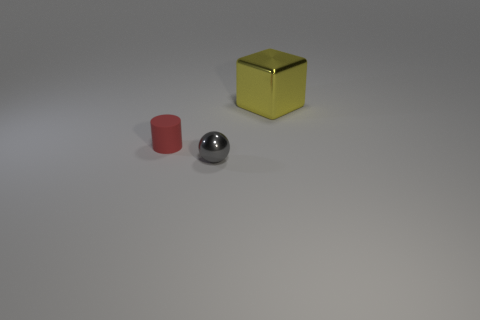Is there a small cylinder of the same color as the tiny metallic object?
Offer a very short reply. No. There is a small object that is to the left of the shiny object in front of the thing on the right side of the gray thing; what is its color?
Make the answer very short. Red. Is the big yellow thing made of the same material as the tiny thing to the left of the gray shiny object?
Make the answer very short. No. What is the yellow block made of?
Provide a short and direct response. Metal. How many other things are the same material as the big cube?
Make the answer very short. 1. There is a thing that is both on the right side of the red matte object and in front of the big yellow thing; what is its shape?
Give a very brief answer. Sphere. There is another thing that is made of the same material as the yellow thing; what is its color?
Offer a terse response. Gray. Are there an equal number of red matte things that are in front of the small rubber cylinder and yellow metallic cylinders?
Keep it short and to the point. Yes. What is the shape of the matte thing that is the same size as the gray metallic object?
Offer a very short reply. Cylinder. What number of other things are the same shape as the tiny metal thing?
Give a very brief answer. 0. 